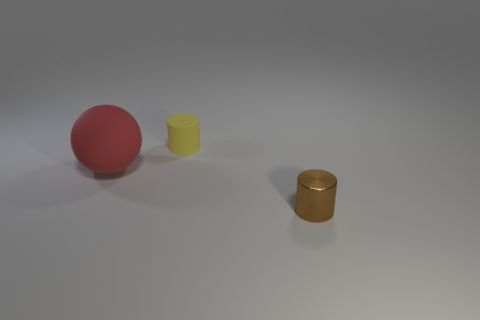What number of brown things are either metallic cylinders or big objects?
Your answer should be very brief. 1. There is a cylinder that is the same material as the large red object; what color is it?
Give a very brief answer. Yellow. Do the small object that is on the left side of the brown cylinder and the small cylinder in front of the large matte sphere have the same material?
Offer a terse response. No. What material is the small cylinder behind the ball?
Ensure brevity in your answer.  Rubber. There is a rubber object that is in front of the small rubber cylinder; does it have the same shape as the object that is behind the red matte thing?
Your answer should be very brief. No. Is there a tiny brown matte cube?
Provide a short and direct response. No. What is the material of the other thing that is the same shape as the brown metallic object?
Keep it short and to the point. Rubber. Are there any things right of the brown cylinder?
Provide a short and direct response. No. Is the tiny object behind the small metallic cylinder made of the same material as the brown object?
Provide a short and direct response. No. Are there any metallic things that have the same color as the tiny shiny cylinder?
Keep it short and to the point. No. 